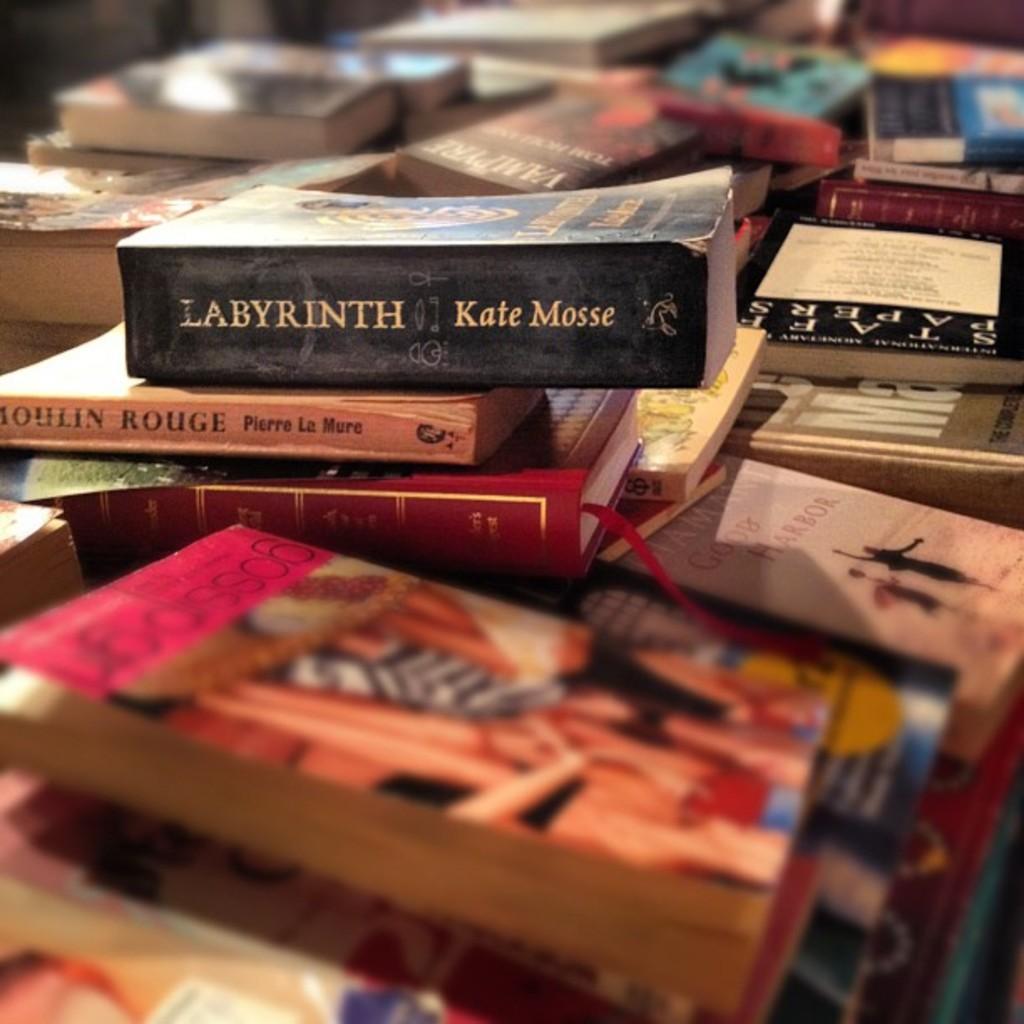Are all those books by the same author?
Your answer should be very brief. No. What is the title of the big black book?
Your answer should be very brief. Labyrinth. 